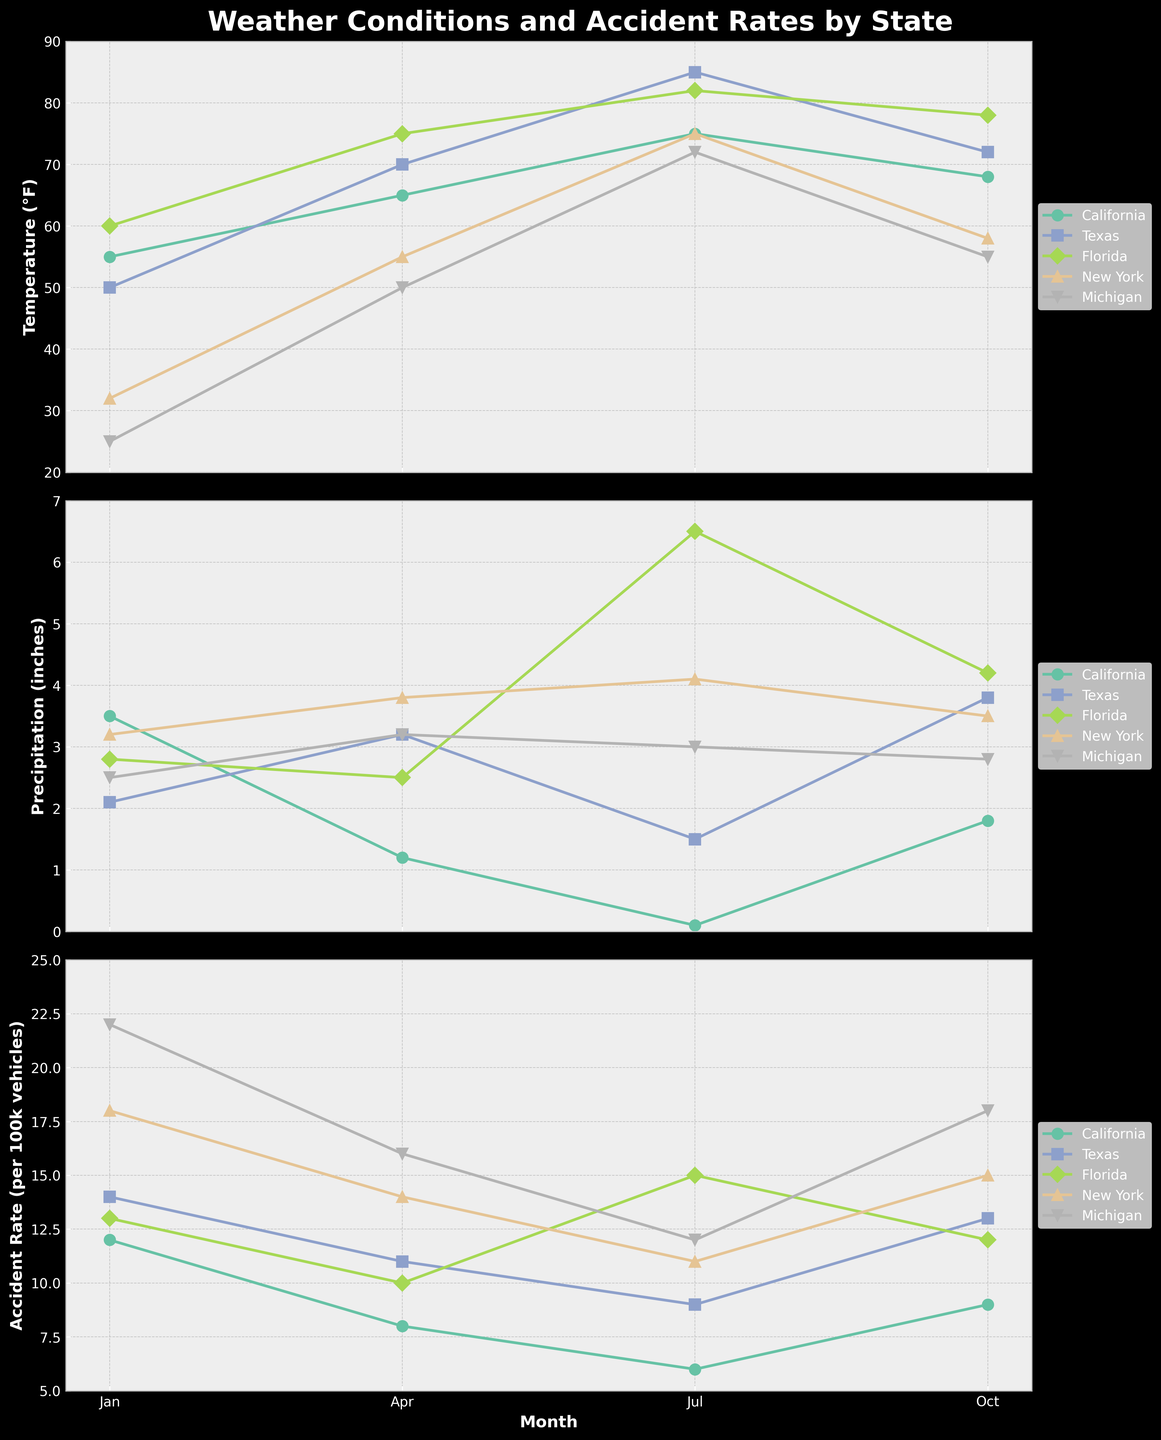What is the title of the figure? The title of the figure is displayed at the top. It reads "Weather Conditions and Accident Rates by State".
Answer: Weather Conditions and Accident Rates by State Which state has the highest accident rate in January? To find the highest accident rate in January, look at the "Accident Rate (per 100k vehicles)" line chart for January. Michigan has the highest value, at 22 per 100k vehicles.
Answer: Michigan Which month has the highest precipitation in Florida? In the "Precipitation (inches)" subplot, look at the line corresponding to Florida. The highest value is in July, at 6.5 inches.
Answer: July How does the accident rate in Michigan change from January to October? Check the data points for Michigan in the "Accident Rate (per 100k vehicles)" subplot for January and October. In January, it's 22, and in October, it's 18, indicating a decrease.
Answer: It decreases Compare the temperature trends in California and New York. Which state shows a greater range? Observe the "Temperature (°F)" subplot. California's temperature ranges from 55°F to 75°F (20°F range), while New York's ranges from 32°F to 75°F (43°F range). Thus, New York shows a greater range.
Answer: New York What is the average accident rate in Texas over the months shown? To find this, add up the accident rates for Texas for each month (14 + 11 + 9 + 13 = 47) and divide by the number of months (4). The average is 47/4 = 11.75.
Answer: 11.75 Which state shows the highest precipitation increase from January to April? Calculate the difference in precipitation from January to April for each state. Texas increases from 2.1 inches to 3.2 inches, a difference of 1.1 inches, which is the highest increase among states.
Answer: Texas What is the total precipitation in New York across all months shown? Sum the "Precipitation (inches)" values for New York (3.2 + 3.8 + 4.1 + 3.5 = 14.6 inches).
Answer: 14.6 inches Which month has the highest accident rate on average across all states? Calculate the average accident rate for each month. January: (12+14+13+18+22)/5 = 15.8, April: (8+11+10+14+16)/5 ≈ 11.8, July: (6+9+15+11+12)/5 ≈ 10.6, October: (9+13+12+15+18)/5 = 13.4. January has the highest average.
Answer: January Which state has the most consistent accident rate across the months shown? The state with the smallest variation in accident rate across months appears most consistent. California ranges from 6 to 12, a range of 6, while Michigan ranges from 12 to 22, a range of 10. California has the lowest range, hence, the most consistent.
Answer: California 